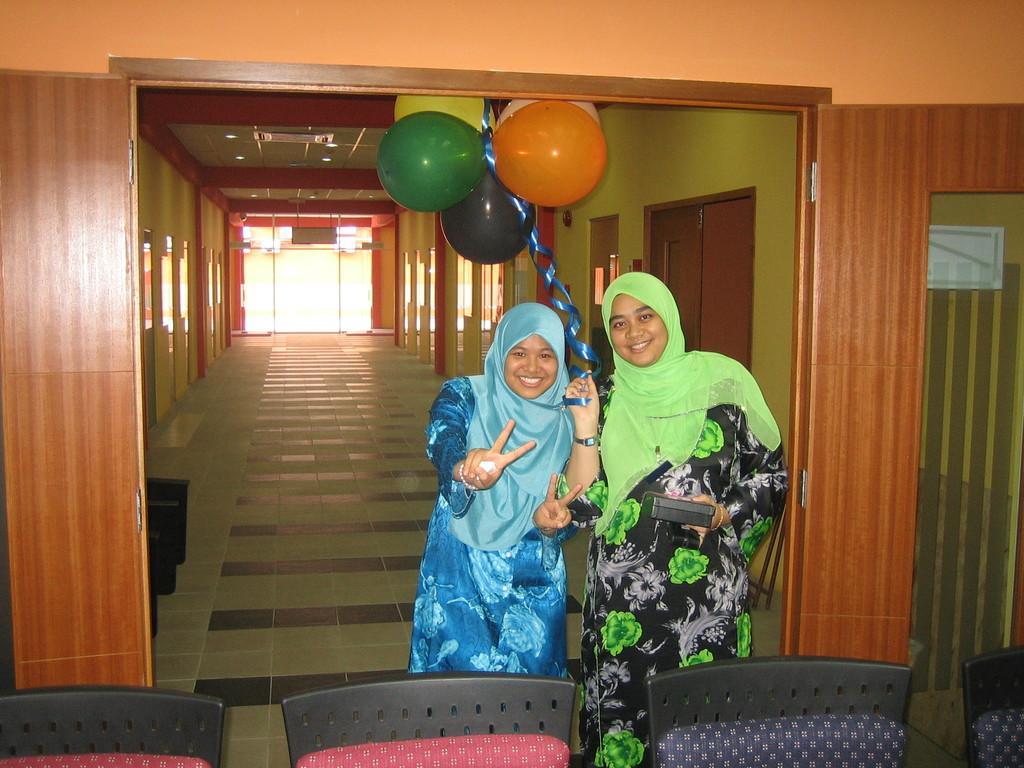In one or two sentences, can you explain what this image depicts? In this image in front there are chairs. Behind the chair there is a person wearing a smile on her face. Beside her there is another person holding the balloons in one hand and some object in another hand. In the background of the image there is a wall. There are closed doors. In the center of the image there is a glass door. On top of the image there are lights. 